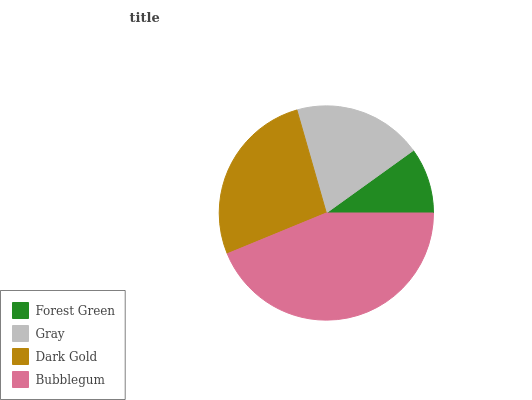Is Forest Green the minimum?
Answer yes or no. Yes. Is Bubblegum the maximum?
Answer yes or no. Yes. Is Gray the minimum?
Answer yes or no. No. Is Gray the maximum?
Answer yes or no. No. Is Gray greater than Forest Green?
Answer yes or no. Yes. Is Forest Green less than Gray?
Answer yes or no. Yes. Is Forest Green greater than Gray?
Answer yes or no. No. Is Gray less than Forest Green?
Answer yes or no. No. Is Dark Gold the high median?
Answer yes or no. Yes. Is Gray the low median?
Answer yes or no. Yes. Is Forest Green the high median?
Answer yes or no. No. Is Bubblegum the low median?
Answer yes or no. No. 